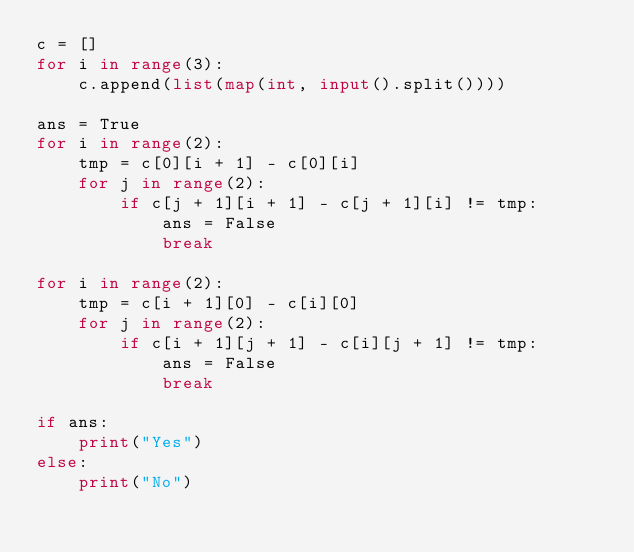Convert code to text. <code><loc_0><loc_0><loc_500><loc_500><_Python_>c = []
for i in range(3):
    c.append(list(map(int, input().split())))

ans = True
for i in range(2):
    tmp = c[0][i + 1] - c[0][i]
    for j in range(2):
        if c[j + 1][i + 1] - c[j + 1][i] != tmp:
            ans = False
            break

for i in range(2):
    tmp = c[i + 1][0] - c[i][0]
    for j in range(2):
        if c[i + 1][j + 1] - c[i][j + 1] != tmp:
            ans = False
            break

if ans:
    print("Yes")
else:
    print("No")
</code> 